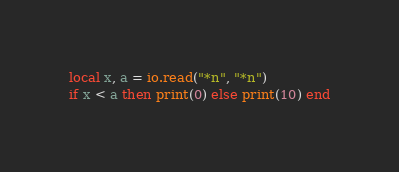<code> <loc_0><loc_0><loc_500><loc_500><_Lua_>local x, a = io.read("*n", "*n")
if x < a then print(0) else print(10) end</code> 